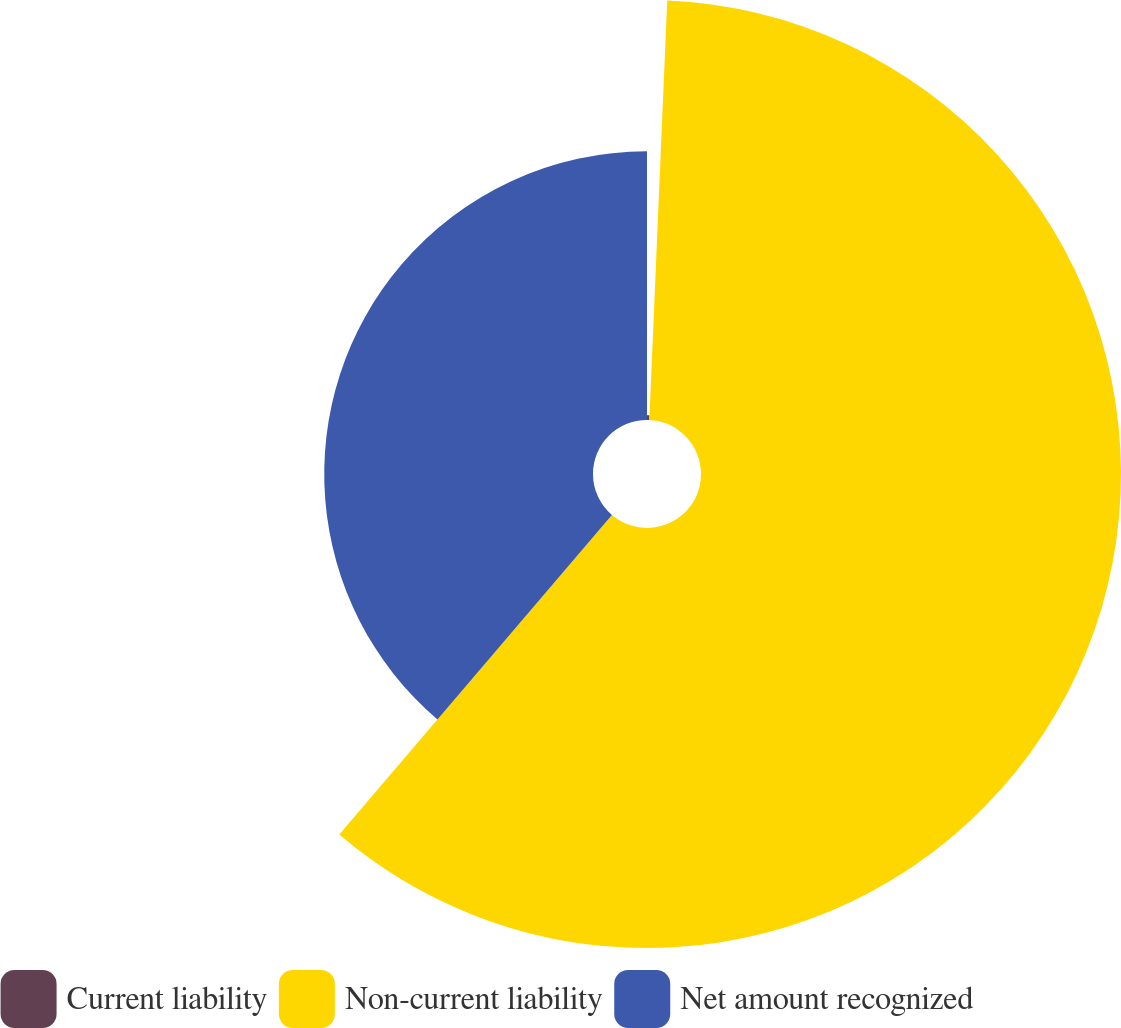Convert chart. <chart><loc_0><loc_0><loc_500><loc_500><pie_chart><fcel>Current liability<fcel>Non-current liability<fcel>Net amount recognized<nl><fcel>0.68%<fcel>60.57%<fcel>38.76%<nl></chart> 